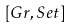<formula> <loc_0><loc_0><loc_500><loc_500>[ G r , S e t ]</formula> 